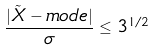Convert formula to latex. <formula><loc_0><loc_0><loc_500><loc_500>\frac { | \tilde { X } - m o d e | } { \sigma } \leq 3 ^ { 1 / 2 }</formula> 